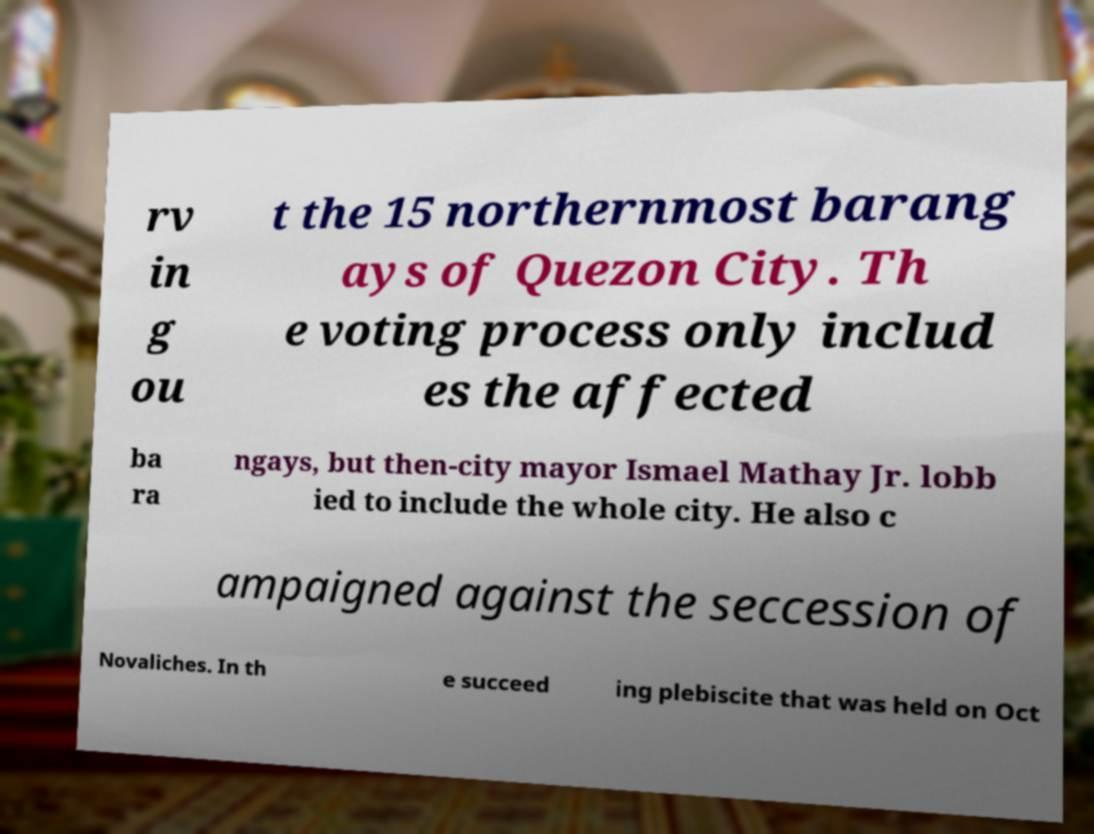Could you assist in decoding the text presented in this image and type it out clearly? rv in g ou t the 15 northernmost barang ays of Quezon City. Th e voting process only includ es the affected ba ra ngays, but then-city mayor Ismael Mathay Jr. lobb ied to include the whole city. He also c ampaigned against the seccession of Novaliches. In th e succeed ing plebiscite that was held on Oct 